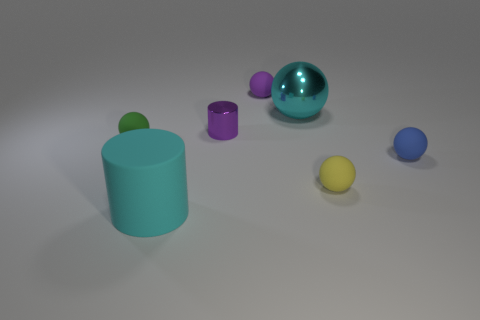Subtract all cyan balls. How many balls are left? 4 Subtract all blue balls. How many balls are left? 4 Subtract 1 balls. How many balls are left? 4 Subtract all gray spheres. Subtract all gray cylinders. How many spheres are left? 5 Add 2 small blue matte spheres. How many objects exist? 9 Subtract all cylinders. How many objects are left? 5 Add 4 big yellow rubber things. How many big yellow rubber things exist? 4 Subtract 0 red blocks. How many objects are left? 7 Subtract all tiny green matte things. Subtract all purple metal cylinders. How many objects are left? 5 Add 1 tiny blue balls. How many tiny blue balls are left? 2 